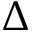Convert formula to latex. <formula><loc_0><loc_0><loc_500><loc_500>\Delta</formula> 